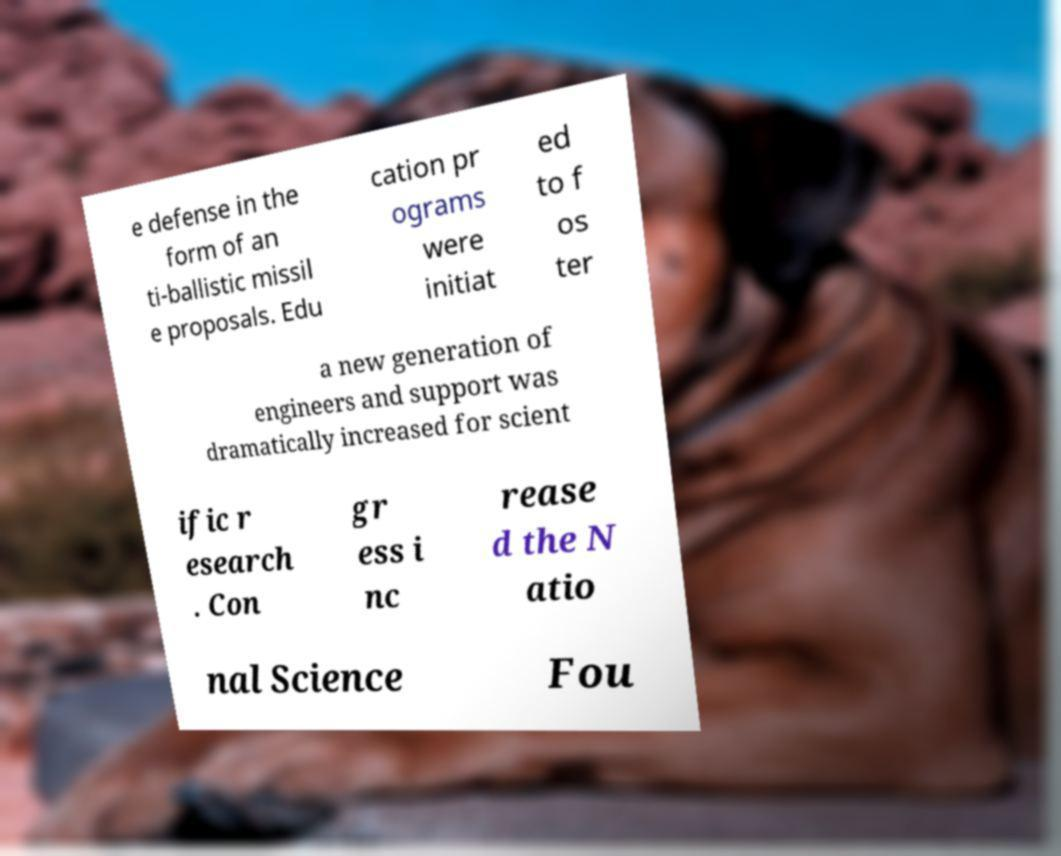Can you read and provide the text displayed in the image?This photo seems to have some interesting text. Can you extract and type it out for me? e defense in the form of an ti-ballistic missil e proposals. Edu cation pr ograms were initiat ed to f os ter a new generation of engineers and support was dramatically increased for scient ific r esearch . Con gr ess i nc rease d the N atio nal Science Fou 